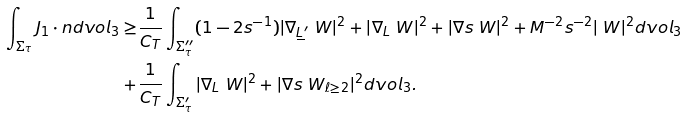<formula> <loc_0><loc_0><loc_500><loc_500>\int _ { \Sigma _ { \tau } } J _ { 1 } \cdot n d v o l _ { 3 } \geq & \frac { 1 } { C _ { T } } \int _ { \Sigma _ { \tau } ^ { \prime \prime } } ( 1 - 2 s ^ { - 1 } ) | \nabla _ { \underline { L } ^ { \prime } } \ W | ^ { 2 } + | \nabla _ { L } \ W | ^ { 2 } + | \nabla s \ W | ^ { 2 } + M ^ { - 2 } s ^ { - 2 } | \ W | ^ { 2 } d v o l _ { 3 } \\ + & \frac { 1 } { C _ { T } } \int _ { \Sigma _ { \tau } ^ { \prime } } | \nabla _ { L } \ W | ^ { 2 } + | \nabla s \ W _ { \ell \geq 2 } | ^ { 2 } d v o l _ { 3 } .</formula> 